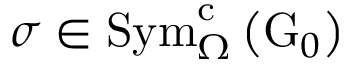<formula> <loc_0><loc_0><loc_500><loc_500>\sigma \in S y m _ { \Omega } ^ { c } \left ( G _ { 0 } \right )</formula> 